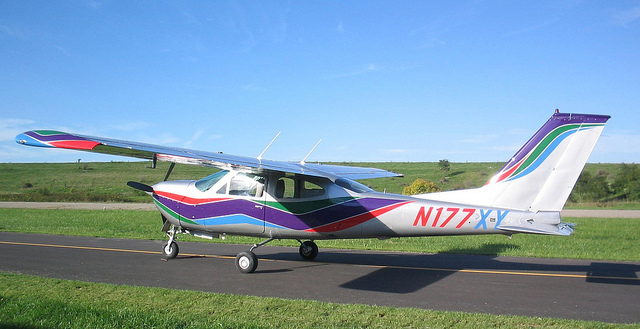Identify the text contained in this image. N177 X-Y 